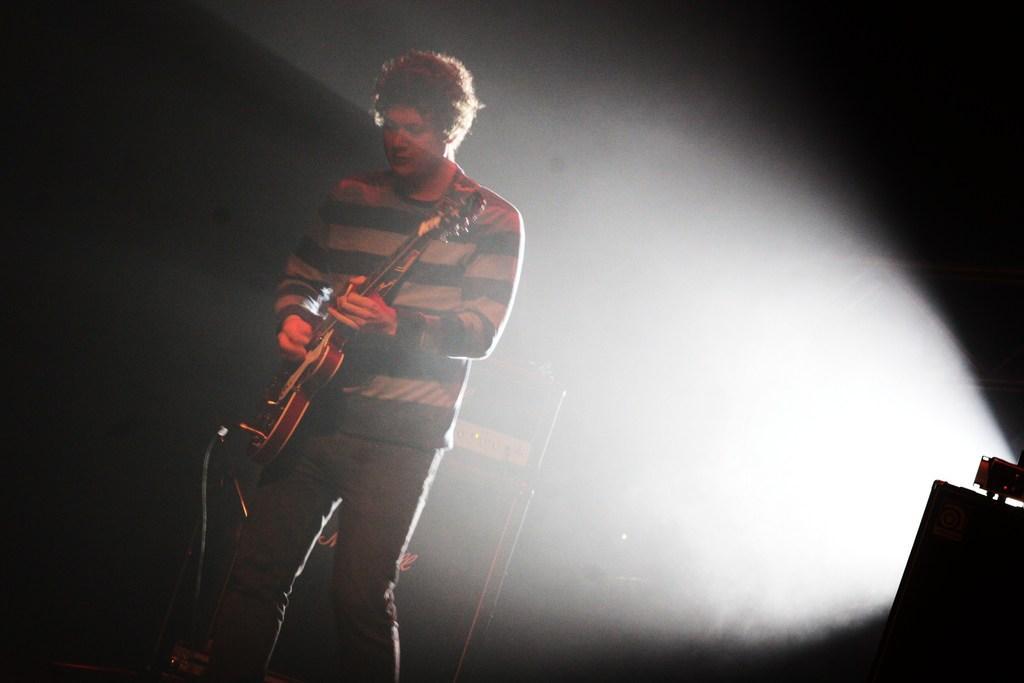Describe this image in one or two sentences. Here we can see a man standing on the floor and he is wearing a t-shirt, and he is playing guitar. 